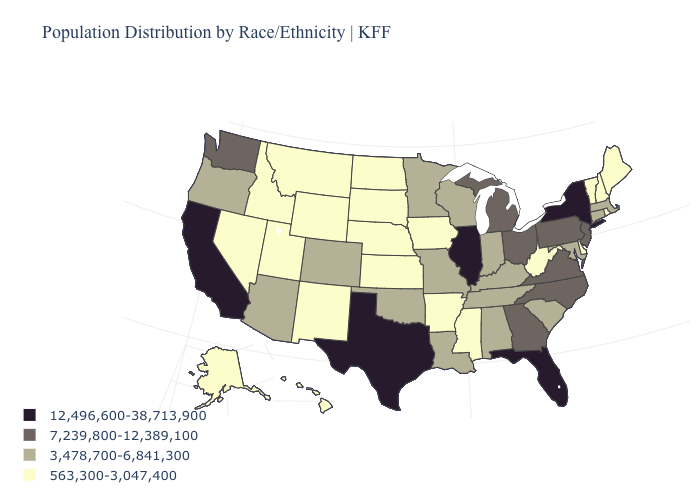Does Alaska have the lowest value in the West?
Keep it brief. Yes. What is the value of Michigan?
Give a very brief answer. 7,239,800-12,389,100. Does Washington have the lowest value in the West?
Keep it brief. No. Name the states that have a value in the range 3,478,700-6,841,300?
Write a very short answer. Alabama, Arizona, Colorado, Connecticut, Indiana, Kentucky, Louisiana, Maryland, Massachusetts, Minnesota, Missouri, Oklahoma, Oregon, South Carolina, Tennessee, Wisconsin. What is the highest value in states that border Missouri?
Short answer required. 12,496,600-38,713,900. Does New York have the highest value in the Northeast?
Be succinct. Yes. What is the highest value in the USA?
Be succinct. 12,496,600-38,713,900. Does Kansas have the same value as Iowa?
Answer briefly. Yes. What is the value of Tennessee?
Give a very brief answer. 3,478,700-6,841,300. Does Colorado have the lowest value in the USA?
Answer briefly. No. How many symbols are there in the legend?
Give a very brief answer. 4. What is the value of Tennessee?
Write a very short answer. 3,478,700-6,841,300. How many symbols are there in the legend?
Quick response, please. 4. What is the value of Texas?
Be succinct. 12,496,600-38,713,900. What is the value of Massachusetts?
Write a very short answer. 3,478,700-6,841,300. 